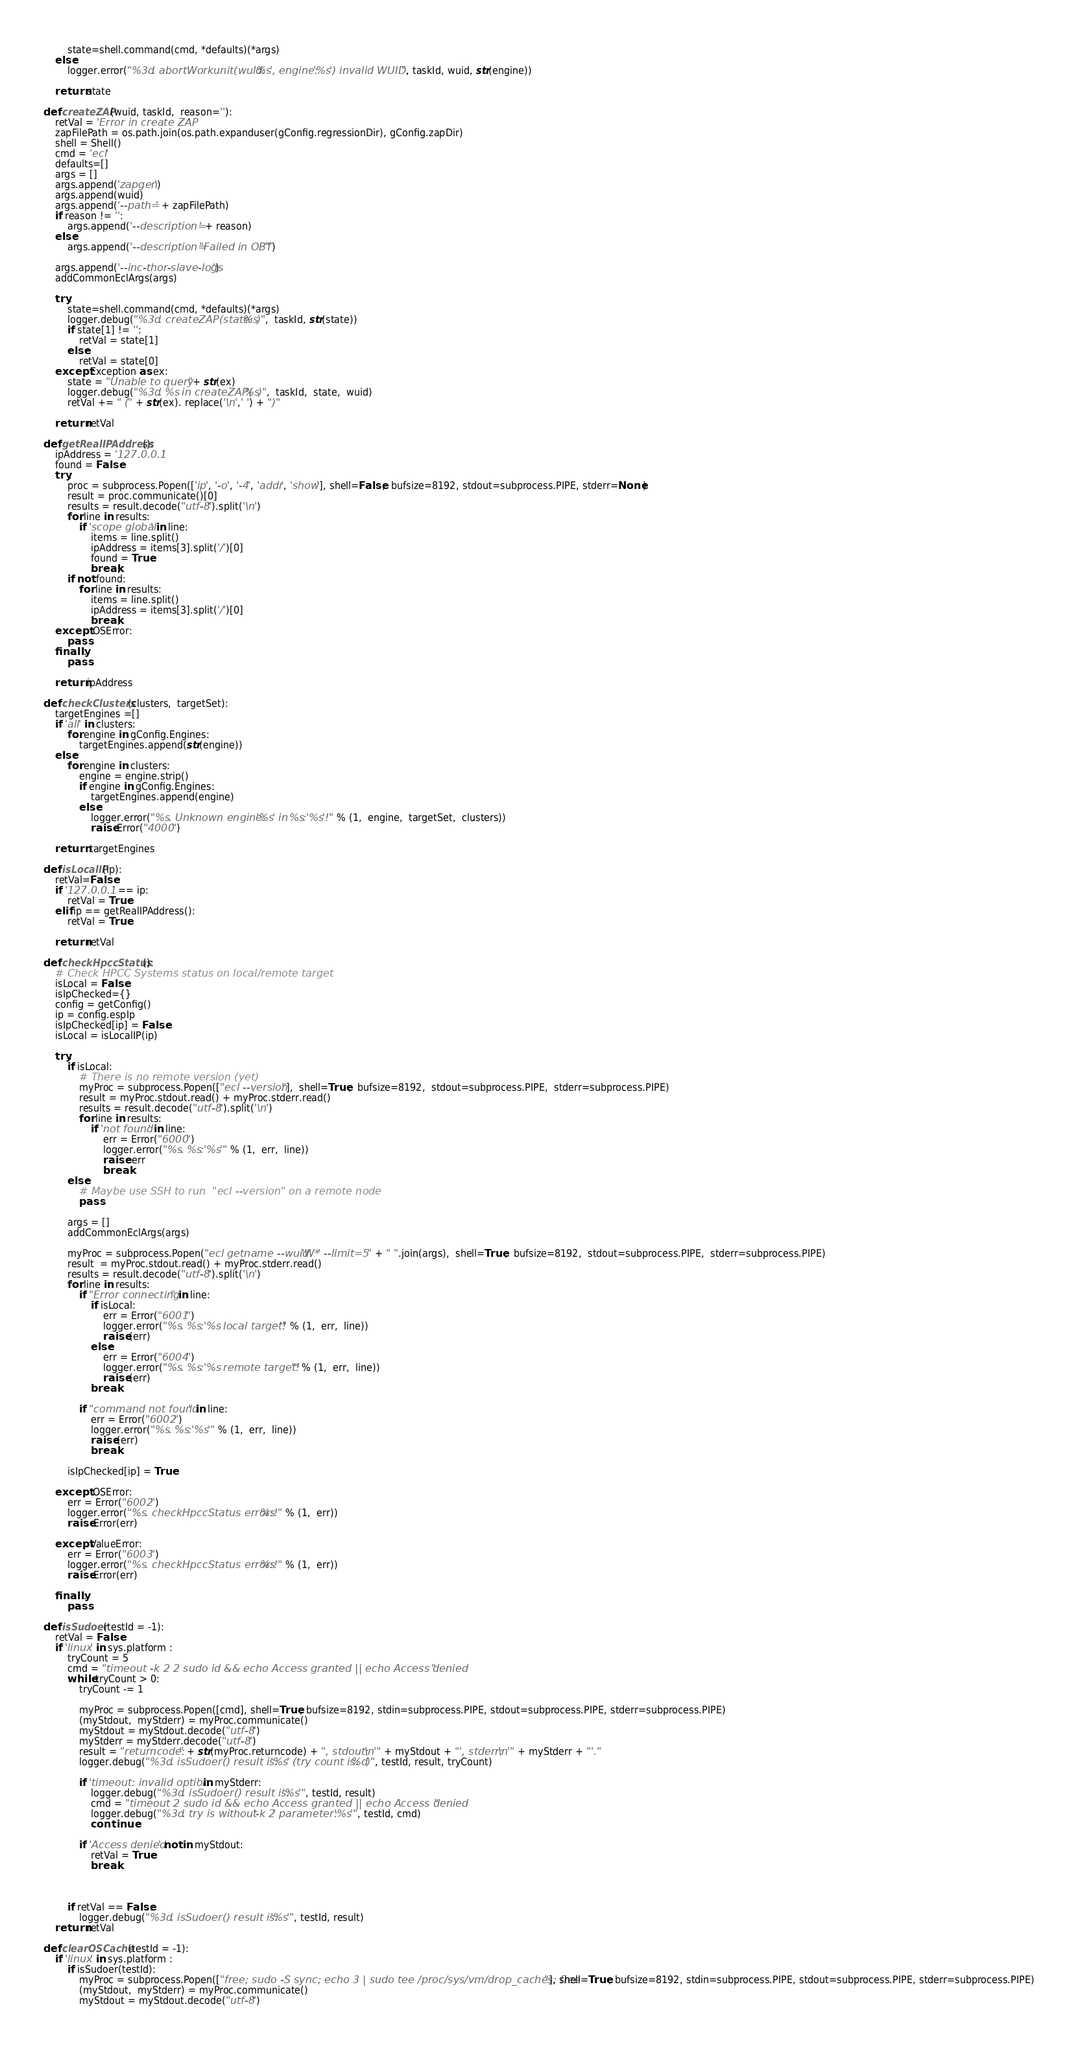<code> <loc_0><loc_0><loc_500><loc_500><_Python_>        state=shell.command(cmd, *defaults)(*args)
    else:
        logger.error("%3d. abortWorkunit(wuid:'%s', engine:'%s') invalid WUID.", taskId, wuid, str(engine))

    return state

def createZAP(wuid, taskId,  reason=''):
    retVal = 'Error in create ZAP'
    zapFilePath = os.path.join(os.path.expanduser(gConfig.regressionDir), gConfig.zapDir)
    shell = Shell()
    cmd = 'ecl'
    defaults=[]
    args = []
    args.append('zapgen')
    args.append(wuid)
    args.append('--path=' + zapFilePath)
    if reason != '':
        args.append('--description=' + reason)
    else:
        args.append('--description="Failed in OBT"')

    args.append('--inc-thor-slave-logs')
    addCommonEclArgs(args)

    try:
        state=shell.command(cmd, *defaults)(*args)
        logger.debug("%3d. createZAP(state:%s)",  taskId, str(state))
        if state[1] != '':
            retVal = state[1]
        else:
            retVal = state[0]
    except Exception as ex:
        state = "Unable to query "+ str(ex)
        logger.debug("%3d. %s in createZAP(%s)",  taskId,  state,  wuid)
        retVal += " (" + str(ex). replace('\n',' ') + ")"

    return retVal

def getRealIPAddress():
    ipAddress = '127.0.0.1'
    found = False
    try:
        proc = subprocess.Popen(['ip', '-o', '-4', 'addr', 'show'], shell=False,  bufsize=8192, stdout=subprocess.PIPE, stderr=None)
        result = proc.communicate()[0]
        results = result.decode("utf-8").split('\n')
        for line in results:
            if 'scope global' in line:
                items = line.split()
                ipAddress = items[3].split('/')[0]
                found = True
                break;
        if not found:
            for line in results:
                items = line.split()
                ipAddress = items[3].split('/')[0]
                break;
    except  OSError:
        pass
    finally:
        pass

    return ipAddress

def checkClusters(clusters,  targetSet):
    targetEngines =[]
    if 'all' in clusters:
        for engine in gConfig.Engines:
            targetEngines.append(str(engine))
    else:
        for engine in clusters:
            engine = engine.strip()
            if engine in gConfig.Engines:
                targetEngines.append(engine)
            else:
                logger.error("%s. Unknown engine:'%s' in %s:'%s'!" % (1,  engine,  targetSet,  clusters))
                raise Error("4000")

    return  targetEngines

def isLocalIP(ip):
    retVal=False
    if '127.0.0.1' == ip:
        retVal = True
    elif ip == getRealIPAddress():
        retVal = True

    return retVal

def checkHpccStatus():
    # Check HPCC Systems status on local/remote target
    isLocal = False
    isIpChecked={}
    config = getConfig()
    ip = config.espIp
    isIpChecked[ip] = False
    isLocal = isLocalIP(ip)

    try:
        if isLocal:
            # There is no remote version (yet)
            myProc = subprocess.Popen(["ecl --version"],  shell=True,  bufsize=8192,  stdout=subprocess.PIPE,  stderr=subprocess.PIPE)
            result = myProc.stdout.read() + myProc.stderr.read()
            results = result.decode("utf-8").split('\n')
            for line in results:
                if 'not found' in line:
                    err = Error("6000")
                    logger.error("%s. %s:'%s'" % (1,  err,  line))
                    raise  err
                    break
        else:
            # Maybe use SSH to run  "ecl --version" on a remote node
            pass

        args = []
        addCommonEclArgs(args)

        myProc = subprocess.Popen("ecl getname --wuid 'W*' --limit=5 " + " ".join(args),  shell=True,  bufsize=8192,  stdout=subprocess.PIPE,  stderr=subprocess.PIPE)
        result  = myProc.stdout.read() + myProc.stderr.read()
        results = result.decode("utf-8").split('\n')
        for line in results:
            if "Error connecting" in line:
                if isLocal:
                    err = Error("6001")
                    logger.error("%s. %s:'%s local target!'" % (1,  err,  line))
                    raise (err)
                else:
                    err = Error("6004")
                    logger.error("%s. %s:'%s remote target!'" % (1,  err,  line))
                    raise (err)
                break

            if "command not found" in line:
                err = Error("6002")
                logger.error("%s. %s:'%s'" % (1,  err,  line))
                raise (err)
                break

        isIpChecked[ip] = True

    except  OSError:
        err = Error("6002")
        logger.error("%s. checkHpccStatus error:%s!" % (1,  err))
        raise Error(err)

    except ValueError:
        err = Error("6003")
        logger.error("%s. checkHpccStatus error:%s!" % (1,  err))
        raise Error(err)

    finally:
        pass

def isSudoer(testId = -1):
    retVal = False
    if 'linux' in sys.platform :
        tryCount = 5
        cmd = "timeout -k 2 2 sudo id && echo Access granted || echo Access denied"
        while tryCount > 0:
            tryCount -= 1
            
            myProc = subprocess.Popen([cmd], shell=True, bufsize=8192, stdin=subprocess.PIPE, stdout=subprocess.PIPE, stderr=subprocess.PIPE)
            (myStdout,  myStderr) = myProc.communicate()
            myStdout = myStdout.decode("utf-8") 
            myStderr = myStderr.decode("utf-8")
            result = "returncode:" + str(myProc.returncode) + ", stdout:\n'" + myStdout + "', stderr:\n'" + myStderr + "'."
            logger.debug("%3d. isSudoer() result is: '%s' (try count is:%d)", testId, result, tryCount)
            
            if 'timeout: invalid option' in myStderr:
                logger.debug("%3d. isSudoer() result is: '%s'", testId, result)
                cmd = "timeout 2 sudo id && echo Access granted || echo Access denied"
                logger.debug("%3d. try is without '-k 2' parameter: '%s'", testId, cmd)
                continue
                
            if 'Access denied' not in myStdout:
                retVal = True
                break



        if retVal == False:
            logger.debug("%3d. isSudoer() result is: '%s'", testId, result)
    return retVal

def clearOSCache(testId = -1):
    if 'linux' in sys.platform :
        if isSudoer(testId):
            myProc = subprocess.Popen(["free; sudo -S sync; echo 3 | sudo tee /proc/sys/vm/drop_caches; free"], shell=True, bufsize=8192, stdin=subprocess.PIPE, stdout=subprocess.PIPE, stderr=subprocess.PIPE)
            (myStdout,  myStderr) = myProc.communicate()
            myStdout = myStdout.decode("utf-8") </code> 